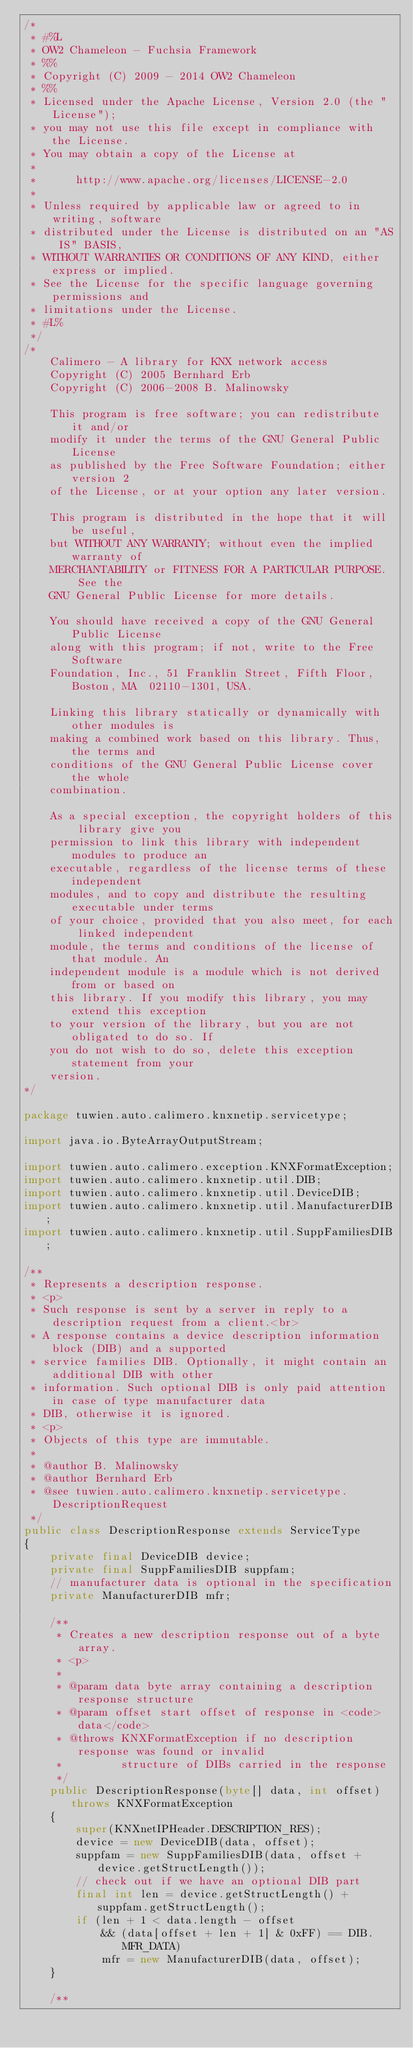<code> <loc_0><loc_0><loc_500><loc_500><_Java_>/*
 * #%L
 * OW2 Chameleon - Fuchsia Framework
 * %%
 * Copyright (C) 2009 - 2014 OW2 Chameleon
 * %%
 * Licensed under the Apache License, Version 2.0 (the "License");
 * you may not use this file except in compliance with the License.
 * You may obtain a copy of the License at
 * 
 *      http://www.apache.org/licenses/LICENSE-2.0
 * 
 * Unless required by applicable law or agreed to in writing, software
 * distributed under the License is distributed on an "AS IS" BASIS,
 * WITHOUT WARRANTIES OR CONDITIONS OF ANY KIND, either express or implied.
 * See the License for the specific language governing permissions and
 * limitations under the License.
 * #L%
 */
/*
    Calimero - A library for KNX network access
    Copyright (C) 2005 Bernhard Erb
    Copyright (C) 2006-2008 B. Malinowsky

    This program is free software; you can redistribute it and/or 
    modify it under the terms of the GNU General Public License 
    as published by the Free Software Foundation; either version 2 
    of the License, or at your option any later version. 
 
    This program is distributed in the hope that it will be useful, 
    but WITHOUT ANY WARRANTY; without even the implied warranty of 
    MERCHANTABILITY or FITNESS FOR A PARTICULAR PURPOSE.  See the 
    GNU General Public License for more details. 
 
    You should have received a copy of the GNU General Public License 
    along with this program; if not, write to the Free Software 
    Foundation, Inc., 51 Franklin Street, Fifth Floor, Boston, MA  02110-1301, USA. 
 
    Linking this library statically or dynamically with other modules is 
    making a combined work based on this library. Thus, the terms and 
    conditions of the GNU General Public License cover the whole 
    combination. 
 
    As a special exception, the copyright holders of this library give you 
    permission to link this library with independent modules to produce an 
    executable, regardless of the license terms of these independent 
    modules, and to copy and distribute the resulting executable under terms 
    of your choice, provided that you also meet, for each linked independent 
    module, the terms and conditions of the license of that module. An 
    independent module is a module which is not derived from or based on 
    this library. If you modify this library, you may extend this exception 
    to your version of the library, but you are not obligated to do so. If 
    you do not wish to do so, delete this exception statement from your 
    version. 
*/

package tuwien.auto.calimero.knxnetip.servicetype;

import java.io.ByteArrayOutputStream;

import tuwien.auto.calimero.exception.KNXFormatException;
import tuwien.auto.calimero.knxnetip.util.DIB;
import tuwien.auto.calimero.knxnetip.util.DeviceDIB;
import tuwien.auto.calimero.knxnetip.util.ManufacturerDIB;
import tuwien.auto.calimero.knxnetip.util.SuppFamiliesDIB;

/**
 * Represents a description response.
 * <p>
 * Such response is sent by a server in reply to a description request from a client.<br>
 * A response contains a device description information block (DIB) and a supported
 * service families DIB. Optionally, it might contain an additional DIB with other
 * information. Such optional DIB is only paid attention in case of type manufacturer data
 * DIB, otherwise it is ignored.
 * <p>
 * Objects of this type are immutable.
 * 
 * @author B. Malinowsky
 * @author Bernhard Erb
 * @see tuwien.auto.calimero.knxnetip.servicetype.DescriptionRequest
 */
public class DescriptionResponse extends ServiceType
{
	private final DeviceDIB device;
	private final SuppFamiliesDIB suppfam;
	// manufacturer data is optional in the specification
	private ManufacturerDIB mfr;

	/**
	 * Creates a new description response out of a byte array.
	 * <p>
	 * 
	 * @param data byte array containing a description response structure
	 * @param offset start offset of response in <code>data</code>
	 * @throws KNXFormatException if no description response was found or invalid
	 *         structure of DIBs carried in the response
	 */
	public DescriptionResponse(byte[] data, int offset) throws KNXFormatException
	{
		super(KNXnetIPHeader.DESCRIPTION_RES);
		device = new DeviceDIB(data, offset);
		suppfam = new SuppFamiliesDIB(data, offset + device.getStructLength());
		// check out if we have an optional DIB part
		final int len = device.getStructLength() + suppfam.getStructLength();
		if (len + 1 < data.length - offset
			&& (data[offset + len + 1] & 0xFF) == DIB.MFR_DATA)
			mfr = new ManufacturerDIB(data, offset);
	}

	/**</code> 